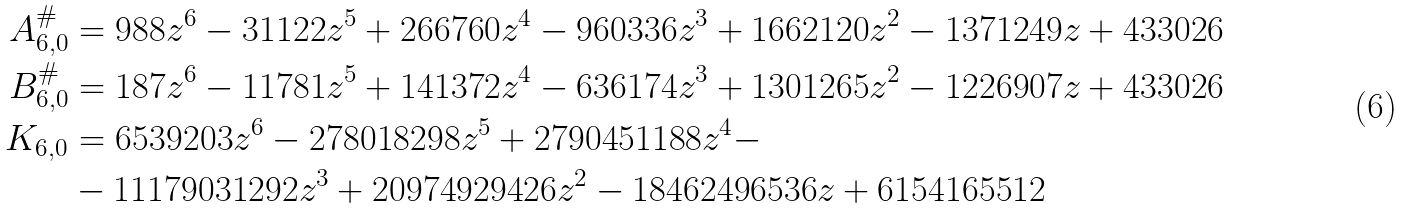<formula> <loc_0><loc_0><loc_500><loc_500>A _ { 6 , 0 } ^ { \# } & = 9 8 8 z ^ { 6 } - 3 1 1 2 2 z ^ { 5 } + 2 6 6 7 6 0 z ^ { 4 } - 9 6 0 3 3 6 z ^ { 3 } + 1 6 6 2 1 2 0 z ^ { 2 } - 1 3 7 1 2 4 9 z + 4 3 3 0 2 6 \\ B _ { 6 , 0 } ^ { \# } & = 1 8 7 z ^ { 6 } - 1 1 7 8 1 z ^ { 5 } + 1 4 1 3 7 2 z ^ { 4 } - 6 3 6 1 7 4 z ^ { 3 } + 1 3 0 1 2 6 5 z ^ { 2 } - 1 2 2 6 9 0 7 z + 4 3 3 0 2 6 \\ K _ { 6 , 0 } & = 6 5 3 9 2 0 3 z ^ { 6 } - 2 7 8 0 1 8 2 9 8 z ^ { 5 } + 2 7 9 0 4 5 1 1 8 8 z ^ { 4 } - \\ & - 1 1 1 7 9 0 3 1 2 9 2 z ^ { 3 } + 2 0 9 7 4 9 2 9 4 2 6 z ^ { 2 } - 1 8 4 6 2 4 9 6 5 3 6 z + 6 1 5 4 1 6 5 5 1 2</formula> 